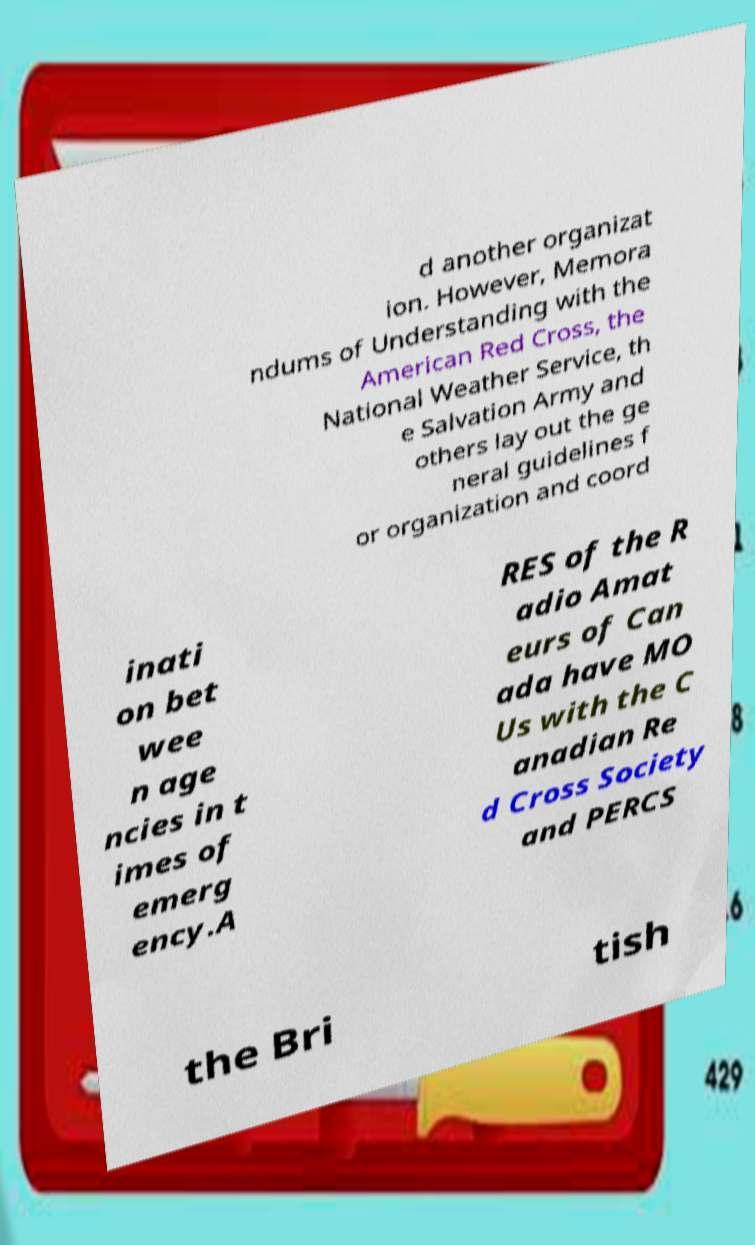Please read and relay the text visible in this image. What does it say? d another organizat ion. However, Memora ndums of Understanding with the American Red Cross, the National Weather Service, th e Salvation Army and others lay out the ge neral guidelines f or organization and coord inati on bet wee n age ncies in t imes of emerg ency.A RES of the R adio Amat eurs of Can ada have MO Us with the C anadian Re d Cross Society and PERCS the Bri tish 